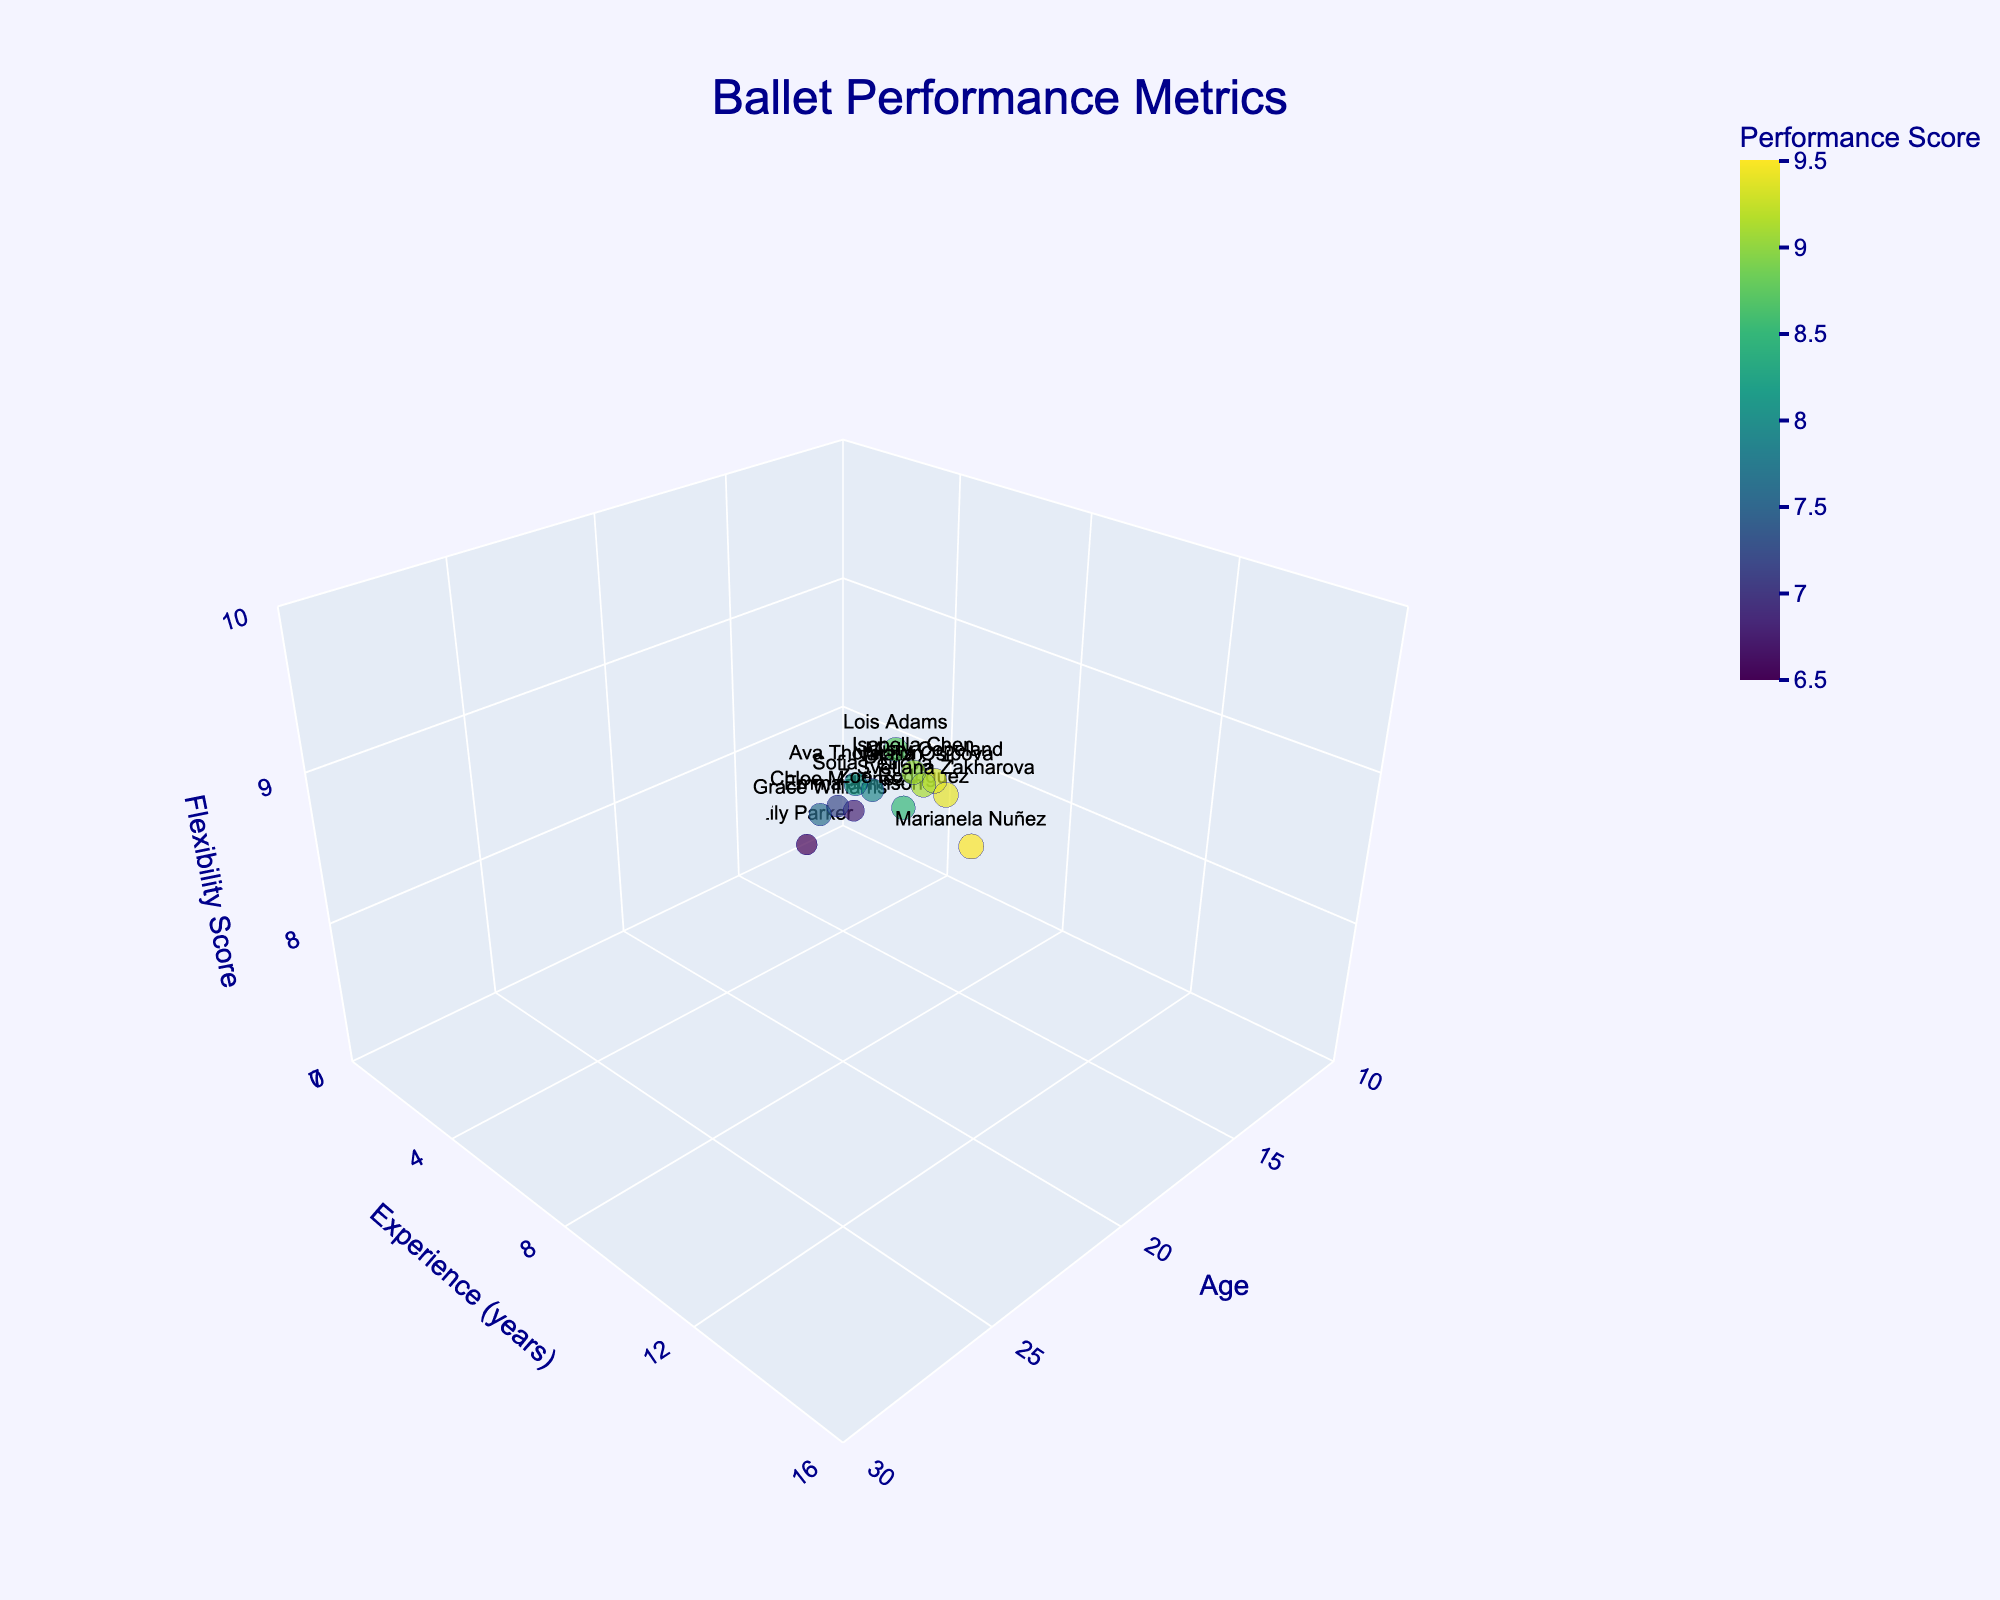What's the title of the figure? The title is written at the top center of the plot. It indicates that the plot represents ballet performance metrics.
Answer: Ballet Performance Metrics How many dancers are shown in the plot? The number of data points in the 3D scatter plot corresponds to the number of dancers. Each dancer’s name can be seen on the plot when hovered over or viewed.
Answer: 13 Which dancer has the highest performance score? By examining the color and size of the data points, the largest and darkest-colored point represents the highest performance score. This is for Marianela Nuñez with a score of 9.5.
Answer: Marianela Nuñez Who is the youngest dancer, and what is her flexibility score? By looking at the X-axis (Age), the youngest dancer is at the far left. When hovered over or highlighted, Emma Johnson is the youngest at 12 years, with a flexibility score of 7.5.
Answer: Emma Johnson, 7.5 What is the relationship between experience and age among the dancers? Generally, the Y-axis (Experience) increases along with the X-axis (Age), indicating that older dancers tend to have more years of experience in ballet.
Answer: Older dancers have more experience Which dancer has the highest flexibility score, and what is her age and experience? The highest point on the Z-axis (Flexibility) represents the highest flexibility score. Hovering or viewing the data reveals that Svetlana Zakharova has a flexibility score of 9.7, age 23, and 13 years of experience.
Answer: Svetlana Zakharova, age 23, experience 13 years How does Lois Adams' performance score compare with other dancers around her age? Lois Adams is 18 years old with a performance score of 8.7. By comparing the nearby points on the X-axis (Age), she has a higher performance score than most dancers around her age except for Misty Copeland.
Answer: Higher than most around her age What is the average flexibility score of dancers aged 20 to 23? Identify the dancers aged 20, 21, 22, and 23 (Isabella Chen, Natalia Osipova, Misty Copeland, Svetlana Zakharova). Their flexibility scores are 9.2, 9.3, 9.5, and 9.6. Calculate the average of these scores (9.2 + 9.3 + 9.5 + 9.6)/4 = 9.4.
Answer: 9.4 Who has more experience, Lois Adams or Chloe Martinez? By looking at the Y-axis (Experience), Lois Adams has 8 years of experience and Chloe Martinez has 3 years of experience.
Answer: Lois Adams Which dancer has the highest flexibility score among those with less than 5 years of experience? Examine the Y-axis for dancers with less than 5 years of experience and then check their Z-axis values. Grace Williams has the highest flexibility score of 8.0 among those with less than 5 years of experience.
Answer: Grace Williams 